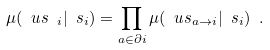<formula> <loc_0><loc_0><loc_500><loc_500>\mu ( \ u s _ { \ i } | \ s _ { i } ) = \prod _ { a \in \partial i } \mu ( \ u s _ { a \to i } | \ s _ { i } ) \ .</formula> 